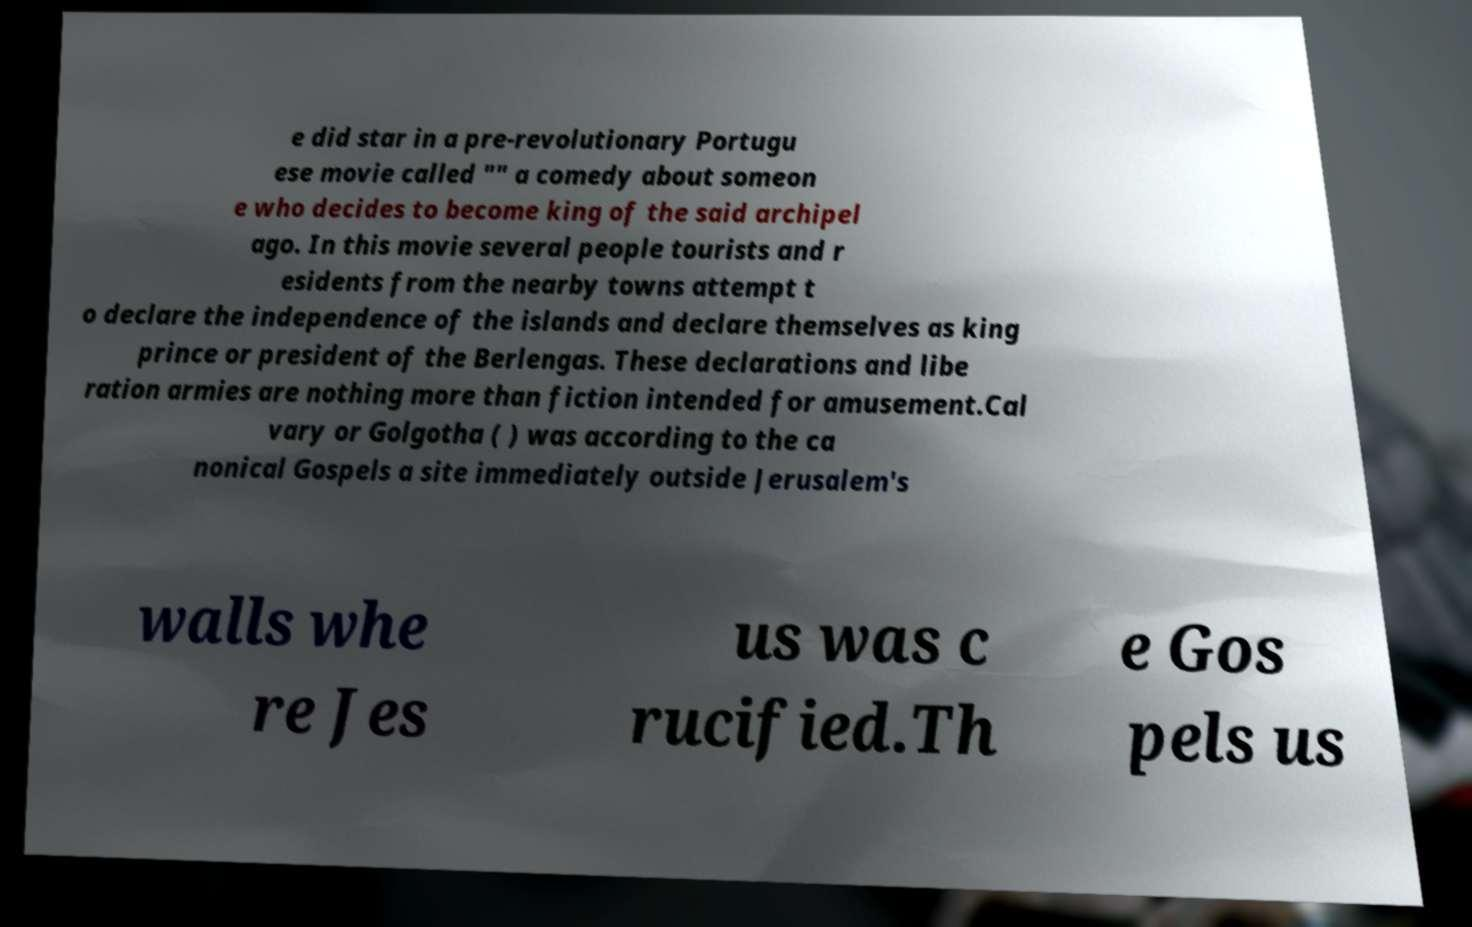Please read and relay the text visible in this image. What does it say? e did star in a pre-revolutionary Portugu ese movie called "" a comedy about someon e who decides to become king of the said archipel ago. In this movie several people tourists and r esidents from the nearby towns attempt t o declare the independence of the islands and declare themselves as king prince or president of the Berlengas. These declarations and libe ration armies are nothing more than fiction intended for amusement.Cal vary or Golgotha ( ) was according to the ca nonical Gospels a site immediately outside Jerusalem's walls whe re Jes us was c rucified.Th e Gos pels us 